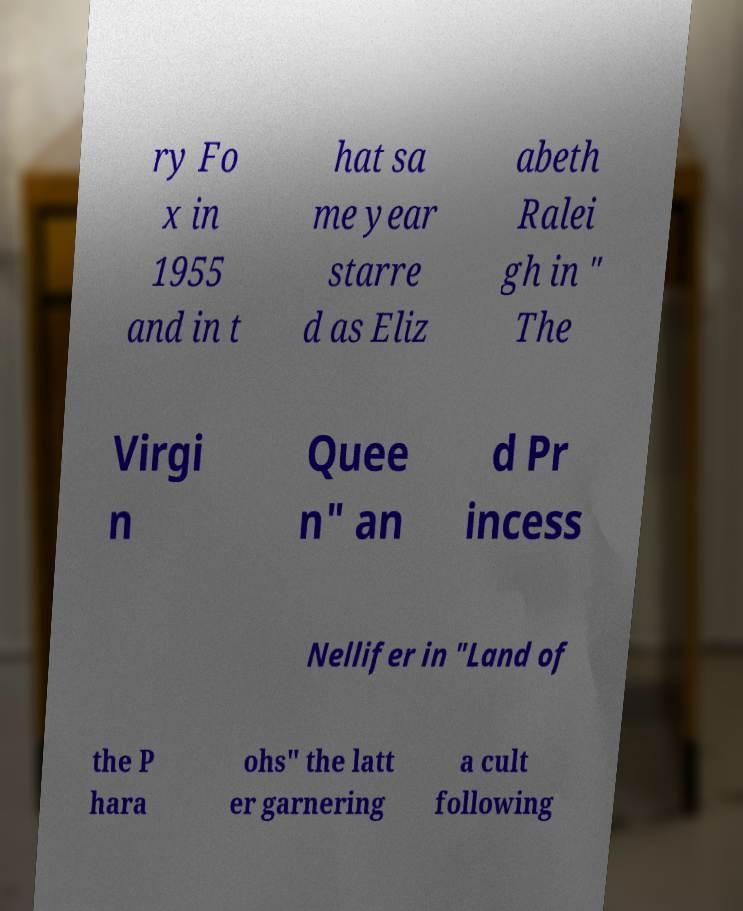I need the written content from this picture converted into text. Can you do that? ry Fo x in 1955 and in t hat sa me year starre d as Eliz abeth Ralei gh in " The Virgi n Quee n" an d Pr incess Nellifer in "Land of the P hara ohs" the latt er garnering a cult following 